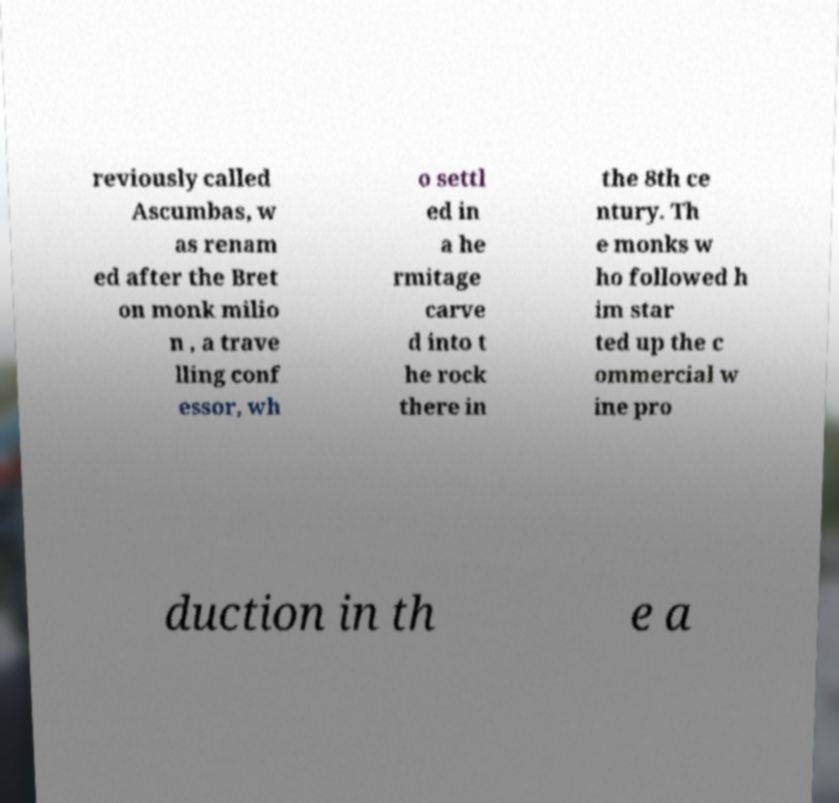For documentation purposes, I need the text within this image transcribed. Could you provide that? reviously called Ascumbas, w as renam ed after the Bret on monk milio n , a trave lling conf essor, wh o settl ed in a he rmitage carve d into t he rock there in the 8th ce ntury. Th e monks w ho followed h im star ted up the c ommercial w ine pro duction in th e a 